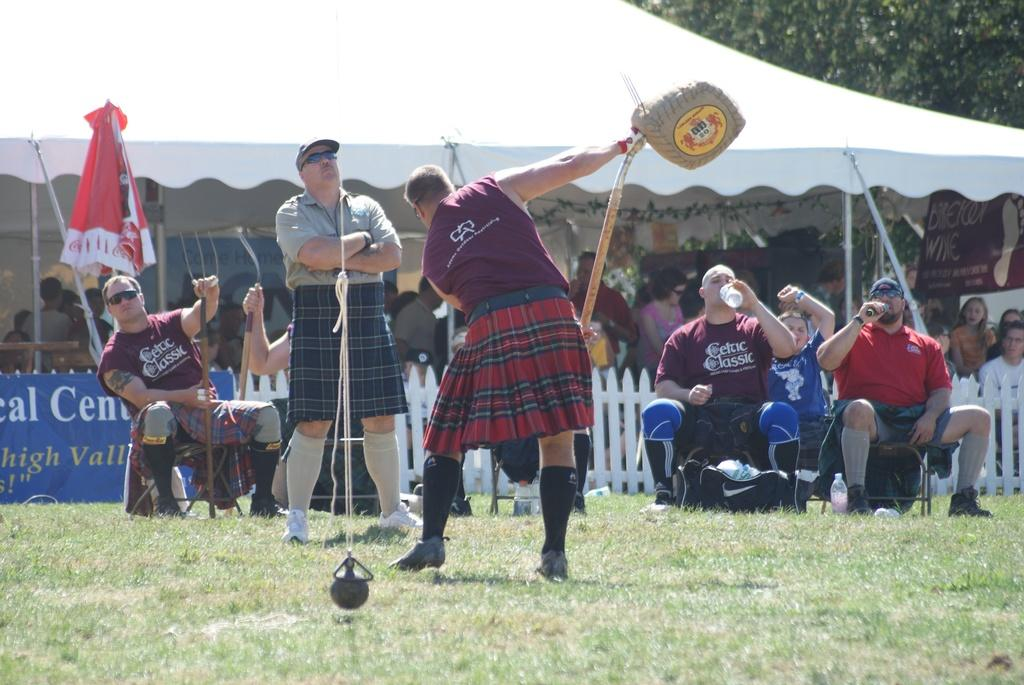What is the person in the image doing? The person is performing an activity in the image. What is the crowd in the image doing? The crowd is enjoying a play. Where is the gathering taking place? The gathering takes place in an open area. What is the weather like in the image? The climate is sunny. What note is the person playing on their instrument in the image? There is no instrument or note mentioned in the image; the person is performing an activity, but the specifics are not provided. 